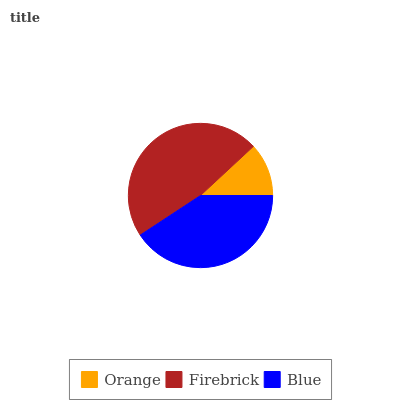Is Orange the minimum?
Answer yes or no. Yes. Is Firebrick the maximum?
Answer yes or no. Yes. Is Blue the minimum?
Answer yes or no. No. Is Blue the maximum?
Answer yes or no. No. Is Firebrick greater than Blue?
Answer yes or no. Yes. Is Blue less than Firebrick?
Answer yes or no. Yes. Is Blue greater than Firebrick?
Answer yes or no. No. Is Firebrick less than Blue?
Answer yes or no. No. Is Blue the high median?
Answer yes or no. Yes. Is Blue the low median?
Answer yes or no. Yes. Is Orange the high median?
Answer yes or no. No. Is Firebrick the low median?
Answer yes or no. No. 